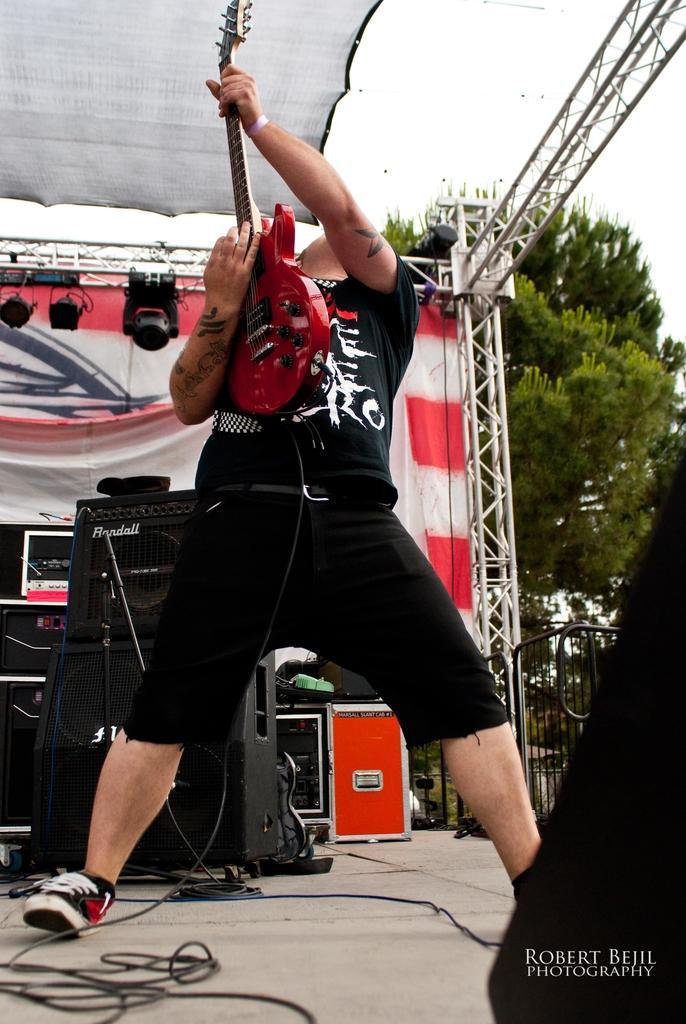Please provide a concise description of this image. In this image we can see a man is standing. He is wearing black color t-shirt and shirt. And playing guitar. Behind him sound boxes, lights, curtain and crane is there. Left bottom of the image wire is present on the floor. Right bottom of the image one person is there and watermark is there. Background of the image trees are are there. At the top of the image shelter is there. 